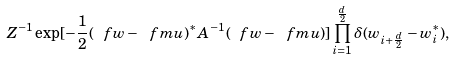Convert formula to latex. <formula><loc_0><loc_0><loc_500><loc_500>Z ^ { - 1 } \exp [ - \frac { 1 } { 2 } ( \ f w - \ f m u ) ^ { * } A ^ { - 1 } ( \ f w - \ f m u ) ] \prod _ { i = 1 } ^ { \frac { d } { 2 } } \delta ( w _ { i + \frac { d } { 2 } } - w _ { i } ^ { * } ) ,</formula> 